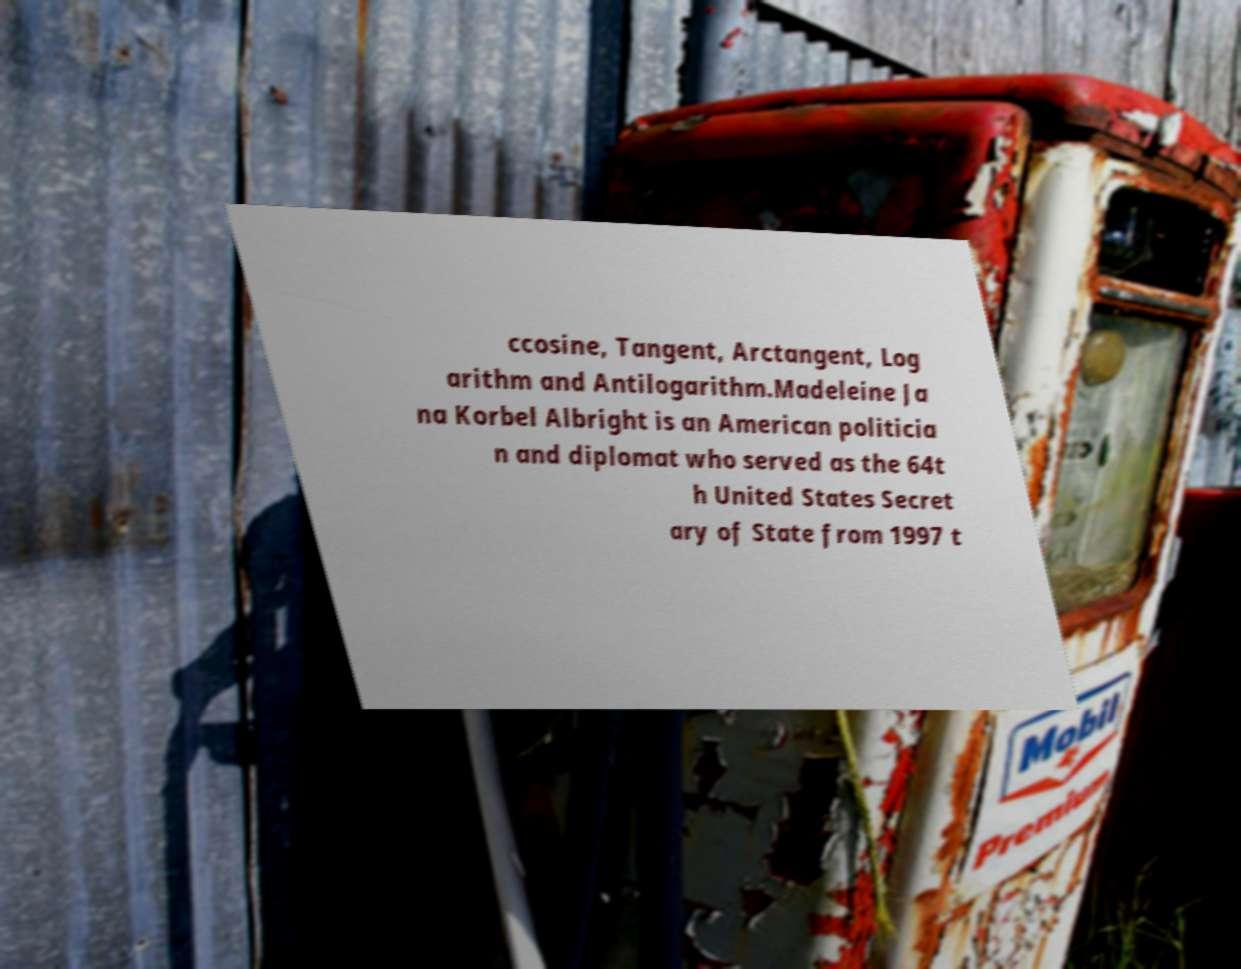For documentation purposes, I need the text within this image transcribed. Could you provide that? ccosine, Tangent, Arctangent, Log arithm and Antilogarithm.Madeleine Ja na Korbel Albright is an American politicia n and diplomat who served as the 64t h United States Secret ary of State from 1997 t 